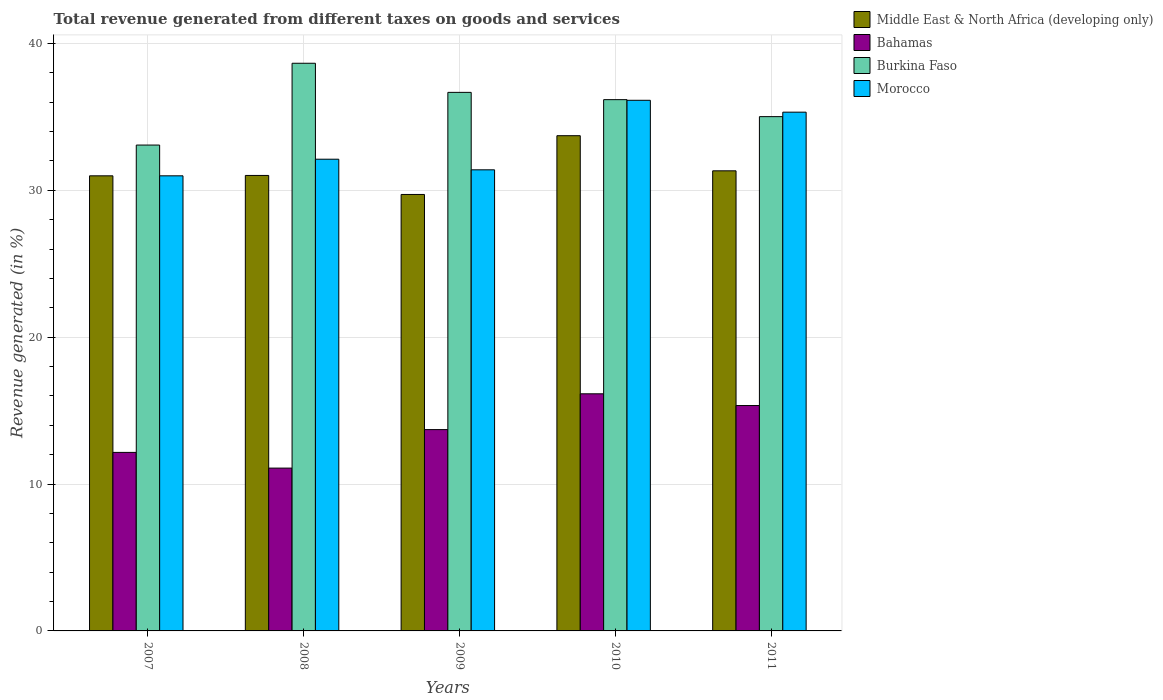How many different coloured bars are there?
Provide a succinct answer. 4. How many groups of bars are there?
Your response must be concise. 5. How many bars are there on the 2nd tick from the left?
Provide a succinct answer. 4. In how many cases, is the number of bars for a given year not equal to the number of legend labels?
Keep it short and to the point. 0. What is the total revenue generated in Morocco in 2009?
Provide a short and direct response. 31.4. Across all years, what is the maximum total revenue generated in Morocco?
Ensure brevity in your answer.  36.13. Across all years, what is the minimum total revenue generated in Middle East & North Africa (developing only)?
Provide a short and direct response. 29.72. In which year was the total revenue generated in Bahamas maximum?
Make the answer very short. 2010. In which year was the total revenue generated in Morocco minimum?
Offer a very short reply. 2007. What is the total total revenue generated in Burkina Faso in the graph?
Your answer should be compact. 179.61. What is the difference between the total revenue generated in Morocco in 2009 and that in 2010?
Keep it short and to the point. -4.73. What is the difference between the total revenue generated in Morocco in 2011 and the total revenue generated in Burkina Faso in 2010?
Make the answer very short. -0.85. What is the average total revenue generated in Morocco per year?
Ensure brevity in your answer.  33.19. In the year 2010, what is the difference between the total revenue generated in Middle East & North Africa (developing only) and total revenue generated in Burkina Faso?
Your answer should be very brief. -2.45. What is the ratio of the total revenue generated in Bahamas in 2009 to that in 2011?
Your answer should be very brief. 0.89. Is the total revenue generated in Burkina Faso in 2009 less than that in 2011?
Give a very brief answer. No. What is the difference between the highest and the second highest total revenue generated in Middle East & North Africa (developing only)?
Provide a succinct answer. 2.39. What is the difference between the highest and the lowest total revenue generated in Middle East & North Africa (developing only)?
Provide a succinct answer. 4. In how many years, is the total revenue generated in Burkina Faso greater than the average total revenue generated in Burkina Faso taken over all years?
Keep it short and to the point. 3. Is the sum of the total revenue generated in Middle East & North Africa (developing only) in 2008 and 2011 greater than the maximum total revenue generated in Bahamas across all years?
Your answer should be compact. Yes. Is it the case that in every year, the sum of the total revenue generated in Burkina Faso and total revenue generated in Middle East & North Africa (developing only) is greater than the sum of total revenue generated in Bahamas and total revenue generated in Morocco?
Provide a succinct answer. No. What does the 2nd bar from the left in 2009 represents?
Offer a terse response. Bahamas. What does the 3rd bar from the right in 2009 represents?
Offer a very short reply. Bahamas. Is it the case that in every year, the sum of the total revenue generated in Burkina Faso and total revenue generated in Bahamas is greater than the total revenue generated in Middle East & North Africa (developing only)?
Provide a succinct answer. Yes. Does the graph contain any zero values?
Keep it short and to the point. No. Does the graph contain grids?
Your answer should be very brief. Yes. How are the legend labels stacked?
Your response must be concise. Vertical. What is the title of the graph?
Offer a terse response. Total revenue generated from different taxes on goods and services. Does "East Asia (all income levels)" appear as one of the legend labels in the graph?
Provide a short and direct response. No. What is the label or title of the Y-axis?
Your answer should be very brief. Revenue generated (in %). What is the Revenue generated (in %) of Middle East & North Africa (developing only) in 2007?
Your answer should be compact. 30.99. What is the Revenue generated (in %) in Bahamas in 2007?
Keep it short and to the point. 12.16. What is the Revenue generated (in %) of Burkina Faso in 2007?
Your answer should be compact. 33.08. What is the Revenue generated (in %) of Morocco in 2007?
Your response must be concise. 30.99. What is the Revenue generated (in %) of Middle East & North Africa (developing only) in 2008?
Provide a short and direct response. 31.02. What is the Revenue generated (in %) in Bahamas in 2008?
Make the answer very short. 11.09. What is the Revenue generated (in %) in Burkina Faso in 2008?
Your response must be concise. 38.66. What is the Revenue generated (in %) in Morocco in 2008?
Make the answer very short. 32.12. What is the Revenue generated (in %) in Middle East & North Africa (developing only) in 2009?
Your answer should be very brief. 29.72. What is the Revenue generated (in %) of Bahamas in 2009?
Ensure brevity in your answer.  13.71. What is the Revenue generated (in %) in Burkina Faso in 2009?
Give a very brief answer. 36.67. What is the Revenue generated (in %) of Morocco in 2009?
Offer a very short reply. 31.4. What is the Revenue generated (in %) in Middle East & North Africa (developing only) in 2010?
Provide a succinct answer. 33.72. What is the Revenue generated (in %) of Bahamas in 2010?
Provide a short and direct response. 16.15. What is the Revenue generated (in %) in Burkina Faso in 2010?
Offer a terse response. 36.18. What is the Revenue generated (in %) in Morocco in 2010?
Make the answer very short. 36.13. What is the Revenue generated (in %) in Middle East & North Africa (developing only) in 2011?
Provide a succinct answer. 31.33. What is the Revenue generated (in %) of Bahamas in 2011?
Offer a very short reply. 15.35. What is the Revenue generated (in %) in Burkina Faso in 2011?
Make the answer very short. 35.02. What is the Revenue generated (in %) of Morocco in 2011?
Offer a very short reply. 35.33. Across all years, what is the maximum Revenue generated (in %) in Middle East & North Africa (developing only)?
Your answer should be compact. 33.72. Across all years, what is the maximum Revenue generated (in %) of Bahamas?
Keep it short and to the point. 16.15. Across all years, what is the maximum Revenue generated (in %) of Burkina Faso?
Provide a short and direct response. 38.66. Across all years, what is the maximum Revenue generated (in %) in Morocco?
Offer a terse response. 36.13. Across all years, what is the minimum Revenue generated (in %) of Middle East & North Africa (developing only)?
Offer a very short reply. 29.72. Across all years, what is the minimum Revenue generated (in %) of Bahamas?
Offer a terse response. 11.09. Across all years, what is the minimum Revenue generated (in %) of Burkina Faso?
Your answer should be compact. 33.08. Across all years, what is the minimum Revenue generated (in %) of Morocco?
Make the answer very short. 30.99. What is the total Revenue generated (in %) of Middle East & North Africa (developing only) in the graph?
Provide a succinct answer. 156.78. What is the total Revenue generated (in %) in Bahamas in the graph?
Your answer should be very brief. 68.45. What is the total Revenue generated (in %) of Burkina Faso in the graph?
Keep it short and to the point. 179.61. What is the total Revenue generated (in %) in Morocco in the graph?
Provide a short and direct response. 165.97. What is the difference between the Revenue generated (in %) of Middle East & North Africa (developing only) in 2007 and that in 2008?
Provide a short and direct response. -0.03. What is the difference between the Revenue generated (in %) of Bahamas in 2007 and that in 2008?
Offer a terse response. 1.07. What is the difference between the Revenue generated (in %) of Burkina Faso in 2007 and that in 2008?
Offer a very short reply. -5.57. What is the difference between the Revenue generated (in %) in Morocco in 2007 and that in 2008?
Offer a very short reply. -1.13. What is the difference between the Revenue generated (in %) in Middle East & North Africa (developing only) in 2007 and that in 2009?
Your response must be concise. 1.27. What is the difference between the Revenue generated (in %) of Bahamas in 2007 and that in 2009?
Provide a short and direct response. -1.55. What is the difference between the Revenue generated (in %) of Burkina Faso in 2007 and that in 2009?
Keep it short and to the point. -3.59. What is the difference between the Revenue generated (in %) in Morocco in 2007 and that in 2009?
Give a very brief answer. -0.41. What is the difference between the Revenue generated (in %) of Middle East & North Africa (developing only) in 2007 and that in 2010?
Your response must be concise. -2.73. What is the difference between the Revenue generated (in %) in Bahamas in 2007 and that in 2010?
Give a very brief answer. -3.99. What is the difference between the Revenue generated (in %) of Burkina Faso in 2007 and that in 2010?
Your answer should be compact. -3.09. What is the difference between the Revenue generated (in %) of Morocco in 2007 and that in 2010?
Ensure brevity in your answer.  -5.14. What is the difference between the Revenue generated (in %) in Middle East & North Africa (developing only) in 2007 and that in 2011?
Give a very brief answer. -0.34. What is the difference between the Revenue generated (in %) in Bahamas in 2007 and that in 2011?
Provide a succinct answer. -3.19. What is the difference between the Revenue generated (in %) of Burkina Faso in 2007 and that in 2011?
Provide a short and direct response. -1.94. What is the difference between the Revenue generated (in %) of Morocco in 2007 and that in 2011?
Provide a succinct answer. -4.34. What is the difference between the Revenue generated (in %) in Middle East & North Africa (developing only) in 2008 and that in 2009?
Your response must be concise. 1.29. What is the difference between the Revenue generated (in %) in Bahamas in 2008 and that in 2009?
Provide a succinct answer. -2.62. What is the difference between the Revenue generated (in %) in Burkina Faso in 2008 and that in 2009?
Your answer should be compact. 1.98. What is the difference between the Revenue generated (in %) in Morocco in 2008 and that in 2009?
Give a very brief answer. 0.72. What is the difference between the Revenue generated (in %) of Middle East & North Africa (developing only) in 2008 and that in 2010?
Your answer should be very brief. -2.71. What is the difference between the Revenue generated (in %) of Bahamas in 2008 and that in 2010?
Your answer should be very brief. -5.06. What is the difference between the Revenue generated (in %) in Burkina Faso in 2008 and that in 2010?
Make the answer very short. 2.48. What is the difference between the Revenue generated (in %) of Morocco in 2008 and that in 2010?
Provide a short and direct response. -4.01. What is the difference between the Revenue generated (in %) of Middle East & North Africa (developing only) in 2008 and that in 2011?
Offer a terse response. -0.31. What is the difference between the Revenue generated (in %) of Bahamas in 2008 and that in 2011?
Make the answer very short. -4.26. What is the difference between the Revenue generated (in %) of Burkina Faso in 2008 and that in 2011?
Ensure brevity in your answer.  3.63. What is the difference between the Revenue generated (in %) of Morocco in 2008 and that in 2011?
Offer a very short reply. -3.2. What is the difference between the Revenue generated (in %) in Middle East & North Africa (developing only) in 2009 and that in 2010?
Make the answer very short. -4. What is the difference between the Revenue generated (in %) in Bahamas in 2009 and that in 2010?
Your answer should be very brief. -2.44. What is the difference between the Revenue generated (in %) in Burkina Faso in 2009 and that in 2010?
Provide a succinct answer. 0.5. What is the difference between the Revenue generated (in %) of Morocco in 2009 and that in 2010?
Your response must be concise. -4.73. What is the difference between the Revenue generated (in %) of Middle East & North Africa (developing only) in 2009 and that in 2011?
Provide a succinct answer. -1.61. What is the difference between the Revenue generated (in %) in Bahamas in 2009 and that in 2011?
Give a very brief answer. -1.64. What is the difference between the Revenue generated (in %) of Burkina Faso in 2009 and that in 2011?
Offer a very short reply. 1.65. What is the difference between the Revenue generated (in %) in Morocco in 2009 and that in 2011?
Make the answer very short. -3.93. What is the difference between the Revenue generated (in %) of Middle East & North Africa (developing only) in 2010 and that in 2011?
Provide a succinct answer. 2.39. What is the difference between the Revenue generated (in %) of Bahamas in 2010 and that in 2011?
Your answer should be compact. 0.8. What is the difference between the Revenue generated (in %) in Burkina Faso in 2010 and that in 2011?
Provide a succinct answer. 1.16. What is the difference between the Revenue generated (in %) in Morocco in 2010 and that in 2011?
Ensure brevity in your answer.  0.81. What is the difference between the Revenue generated (in %) of Middle East & North Africa (developing only) in 2007 and the Revenue generated (in %) of Bahamas in 2008?
Provide a short and direct response. 19.9. What is the difference between the Revenue generated (in %) in Middle East & North Africa (developing only) in 2007 and the Revenue generated (in %) in Burkina Faso in 2008?
Keep it short and to the point. -7.67. What is the difference between the Revenue generated (in %) of Middle East & North Africa (developing only) in 2007 and the Revenue generated (in %) of Morocco in 2008?
Your answer should be compact. -1.13. What is the difference between the Revenue generated (in %) in Bahamas in 2007 and the Revenue generated (in %) in Burkina Faso in 2008?
Provide a succinct answer. -26.5. What is the difference between the Revenue generated (in %) of Bahamas in 2007 and the Revenue generated (in %) of Morocco in 2008?
Ensure brevity in your answer.  -19.97. What is the difference between the Revenue generated (in %) in Burkina Faso in 2007 and the Revenue generated (in %) in Morocco in 2008?
Offer a terse response. 0.96. What is the difference between the Revenue generated (in %) in Middle East & North Africa (developing only) in 2007 and the Revenue generated (in %) in Bahamas in 2009?
Provide a short and direct response. 17.28. What is the difference between the Revenue generated (in %) of Middle East & North Africa (developing only) in 2007 and the Revenue generated (in %) of Burkina Faso in 2009?
Offer a terse response. -5.68. What is the difference between the Revenue generated (in %) in Middle East & North Africa (developing only) in 2007 and the Revenue generated (in %) in Morocco in 2009?
Make the answer very short. -0.41. What is the difference between the Revenue generated (in %) in Bahamas in 2007 and the Revenue generated (in %) in Burkina Faso in 2009?
Offer a very short reply. -24.52. What is the difference between the Revenue generated (in %) of Bahamas in 2007 and the Revenue generated (in %) of Morocco in 2009?
Ensure brevity in your answer.  -19.24. What is the difference between the Revenue generated (in %) of Burkina Faso in 2007 and the Revenue generated (in %) of Morocco in 2009?
Give a very brief answer. 1.69. What is the difference between the Revenue generated (in %) of Middle East & North Africa (developing only) in 2007 and the Revenue generated (in %) of Bahamas in 2010?
Your response must be concise. 14.84. What is the difference between the Revenue generated (in %) in Middle East & North Africa (developing only) in 2007 and the Revenue generated (in %) in Burkina Faso in 2010?
Give a very brief answer. -5.19. What is the difference between the Revenue generated (in %) in Middle East & North Africa (developing only) in 2007 and the Revenue generated (in %) in Morocco in 2010?
Keep it short and to the point. -5.14. What is the difference between the Revenue generated (in %) in Bahamas in 2007 and the Revenue generated (in %) in Burkina Faso in 2010?
Offer a very short reply. -24.02. What is the difference between the Revenue generated (in %) of Bahamas in 2007 and the Revenue generated (in %) of Morocco in 2010?
Give a very brief answer. -23.98. What is the difference between the Revenue generated (in %) in Burkina Faso in 2007 and the Revenue generated (in %) in Morocco in 2010?
Make the answer very short. -3.05. What is the difference between the Revenue generated (in %) of Middle East & North Africa (developing only) in 2007 and the Revenue generated (in %) of Bahamas in 2011?
Ensure brevity in your answer.  15.64. What is the difference between the Revenue generated (in %) of Middle East & North Africa (developing only) in 2007 and the Revenue generated (in %) of Burkina Faso in 2011?
Offer a very short reply. -4.03. What is the difference between the Revenue generated (in %) in Middle East & North Africa (developing only) in 2007 and the Revenue generated (in %) in Morocco in 2011?
Offer a terse response. -4.34. What is the difference between the Revenue generated (in %) of Bahamas in 2007 and the Revenue generated (in %) of Burkina Faso in 2011?
Your answer should be very brief. -22.86. What is the difference between the Revenue generated (in %) in Bahamas in 2007 and the Revenue generated (in %) in Morocco in 2011?
Give a very brief answer. -23.17. What is the difference between the Revenue generated (in %) in Burkina Faso in 2007 and the Revenue generated (in %) in Morocco in 2011?
Your response must be concise. -2.24. What is the difference between the Revenue generated (in %) in Middle East & North Africa (developing only) in 2008 and the Revenue generated (in %) in Bahamas in 2009?
Your answer should be very brief. 17.31. What is the difference between the Revenue generated (in %) in Middle East & North Africa (developing only) in 2008 and the Revenue generated (in %) in Burkina Faso in 2009?
Your response must be concise. -5.66. What is the difference between the Revenue generated (in %) in Middle East & North Africa (developing only) in 2008 and the Revenue generated (in %) in Morocco in 2009?
Offer a very short reply. -0.38. What is the difference between the Revenue generated (in %) of Bahamas in 2008 and the Revenue generated (in %) of Burkina Faso in 2009?
Keep it short and to the point. -25.59. What is the difference between the Revenue generated (in %) in Bahamas in 2008 and the Revenue generated (in %) in Morocco in 2009?
Offer a terse response. -20.31. What is the difference between the Revenue generated (in %) of Burkina Faso in 2008 and the Revenue generated (in %) of Morocco in 2009?
Provide a short and direct response. 7.26. What is the difference between the Revenue generated (in %) in Middle East & North Africa (developing only) in 2008 and the Revenue generated (in %) in Bahamas in 2010?
Give a very brief answer. 14.87. What is the difference between the Revenue generated (in %) of Middle East & North Africa (developing only) in 2008 and the Revenue generated (in %) of Burkina Faso in 2010?
Offer a very short reply. -5.16. What is the difference between the Revenue generated (in %) of Middle East & North Africa (developing only) in 2008 and the Revenue generated (in %) of Morocco in 2010?
Your answer should be compact. -5.12. What is the difference between the Revenue generated (in %) of Bahamas in 2008 and the Revenue generated (in %) of Burkina Faso in 2010?
Offer a very short reply. -25.09. What is the difference between the Revenue generated (in %) of Bahamas in 2008 and the Revenue generated (in %) of Morocco in 2010?
Ensure brevity in your answer.  -25.05. What is the difference between the Revenue generated (in %) in Burkina Faso in 2008 and the Revenue generated (in %) in Morocco in 2010?
Give a very brief answer. 2.52. What is the difference between the Revenue generated (in %) in Middle East & North Africa (developing only) in 2008 and the Revenue generated (in %) in Bahamas in 2011?
Your response must be concise. 15.67. What is the difference between the Revenue generated (in %) in Middle East & North Africa (developing only) in 2008 and the Revenue generated (in %) in Burkina Faso in 2011?
Your answer should be very brief. -4. What is the difference between the Revenue generated (in %) in Middle East & North Africa (developing only) in 2008 and the Revenue generated (in %) in Morocco in 2011?
Offer a very short reply. -4.31. What is the difference between the Revenue generated (in %) of Bahamas in 2008 and the Revenue generated (in %) of Burkina Faso in 2011?
Offer a terse response. -23.93. What is the difference between the Revenue generated (in %) in Bahamas in 2008 and the Revenue generated (in %) in Morocco in 2011?
Make the answer very short. -24.24. What is the difference between the Revenue generated (in %) in Burkina Faso in 2008 and the Revenue generated (in %) in Morocco in 2011?
Offer a terse response. 3.33. What is the difference between the Revenue generated (in %) of Middle East & North Africa (developing only) in 2009 and the Revenue generated (in %) of Bahamas in 2010?
Offer a very short reply. 13.57. What is the difference between the Revenue generated (in %) in Middle East & North Africa (developing only) in 2009 and the Revenue generated (in %) in Burkina Faso in 2010?
Your response must be concise. -6.46. What is the difference between the Revenue generated (in %) of Middle East & North Africa (developing only) in 2009 and the Revenue generated (in %) of Morocco in 2010?
Your answer should be compact. -6.41. What is the difference between the Revenue generated (in %) of Bahamas in 2009 and the Revenue generated (in %) of Burkina Faso in 2010?
Your answer should be very brief. -22.47. What is the difference between the Revenue generated (in %) in Bahamas in 2009 and the Revenue generated (in %) in Morocco in 2010?
Your answer should be very brief. -22.42. What is the difference between the Revenue generated (in %) in Burkina Faso in 2009 and the Revenue generated (in %) in Morocco in 2010?
Ensure brevity in your answer.  0.54. What is the difference between the Revenue generated (in %) of Middle East & North Africa (developing only) in 2009 and the Revenue generated (in %) of Bahamas in 2011?
Your response must be concise. 14.37. What is the difference between the Revenue generated (in %) in Middle East & North Africa (developing only) in 2009 and the Revenue generated (in %) in Burkina Faso in 2011?
Your answer should be compact. -5.3. What is the difference between the Revenue generated (in %) in Middle East & North Africa (developing only) in 2009 and the Revenue generated (in %) in Morocco in 2011?
Offer a very short reply. -5.6. What is the difference between the Revenue generated (in %) of Bahamas in 2009 and the Revenue generated (in %) of Burkina Faso in 2011?
Offer a terse response. -21.31. What is the difference between the Revenue generated (in %) in Bahamas in 2009 and the Revenue generated (in %) in Morocco in 2011?
Offer a very short reply. -21.62. What is the difference between the Revenue generated (in %) of Burkina Faso in 2009 and the Revenue generated (in %) of Morocco in 2011?
Make the answer very short. 1.35. What is the difference between the Revenue generated (in %) of Middle East & North Africa (developing only) in 2010 and the Revenue generated (in %) of Bahamas in 2011?
Your response must be concise. 18.38. What is the difference between the Revenue generated (in %) of Middle East & North Africa (developing only) in 2010 and the Revenue generated (in %) of Burkina Faso in 2011?
Provide a short and direct response. -1.3. What is the difference between the Revenue generated (in %) of Middle East & North Africa (developing only) in 2010 and the Revenue generated (in %) of Morocco in 2011?
Your answer should be compact. -1.6. What is the difference between the Revenue generated (in %) in Bahamas in 2010 and the Revenue generated (in %) in Burkina Faso in 2011?
Give a very brief answer. -18.87. What is the difference between the Revenue generated (in %) of Bahamas in 2010 and the Revenue generated (in %) of Morocco in 2011?
Give a very brief answer. -19.18. What is the difference between the Revenue generated (in %) in Burkina Faso in 2010 and the Revenue generated (in %) in Morocco in 2011?
Ensure brevity in your answer.  0.85. What is the average Revenue generated (in %) in Middle East & North Africa (developing only) per year?
Your response must be concise. 31.36. What is the average Revenue generated (in %) of Bahamas per year?
Keep it short and to the point. 13.69. What is the average Revenue generated (in %) in Burkina Faso per year?
Your response must be concise. 35.92. What is the average Revenue generated (in %) in Morocco per year?
Offer a very short reply. 33.19. In the year 2007, what is the difference between the Revenue generated (in %) of Middle East & North Africa (developing only) and Revenue generated (in %) of Bahamas?
Keep it short and to the point. 18.83. In the year 2007, what is the difference between the Revenue generated (in %) of Middle East & North Africa (developing only) and Revenue generated (in %) of Burkina Faso?
Your answer should be very brief. -2.09. In the year 2007, what is the difference between the Revenue generated (in %) of Bahamas and Revenue generated (in %) of Burkina Faso?
Ensure brevity in your answer.  -20.93. In the year 2007, what is the difference between the Revenue generated (in %) of Bahamas and Revenue generated (in %) of Morocco?
Keep it short and to the point. -18.83. In the year 2007, what is the difference between the Revenue generated (in %) in Burkina Faso and Revenue generated (in %) in Morocco?
Make the answer very short. 2.09. In the year 2008, what is the difference between the Revenue generated (in %) in Middle East & North Africa (developing only) and Revenue generated (in %) in Bahamas?
Your answer should be compact. 19.93. In the year 2008, what is the difference between the Revenue generated (in %) in Middle East & North Africa (developing only) and Revenue generated (in %) in Burkina Faso?
Provide a short and direct response. -7.64. In the year 2008, what is the difference between the Revenue generated (in %) of Middle East & North Africa (developing only) and Revenue generated (in %) of Morocco?
Give a very brief answer. -1.11. In the year 2008, what is the difference between the Revenue generated (in %) of Bahamas and Revenue generated (in %) of Burkina Faso?
Offer a very short reply. -27.57. In the year 2008, what is the difference between the Revenue generated (in %) in Bahamas and Revenue generated (in %) in Morocco?
Provide a succinct answer. -21.03. In the year 2008, what is the difference between the Revenue generated (in %) of Burkina Faso and Revenue generated (in %) of Morocco?
Your answer should be compact. 6.53. In the year 2009, what is the difference between the Revenue generated (in %) of Middle East & North Africa (developing only) and Revenue generated (in %) of Bahamas?
Keep it short and to the point. 16.01. In the year 2009, what is the difference between the Revenue generated (in %) of Middle East & North Africa (developing only) and Revenue generated (in %) of Burkina Faso?
Provide a short and direct response. -6.95. In the year 2009, what is the difference between the Revenue generated (in %) of Middle East & North Africa (developing only) and Revenue generated (in %) of Morocco?
Ensure brevity in your answer.  -1.68. In the year 2009, what is the difference between the Revenue generated (in %) in Bahamas and Revenue generated (in %) in Burkina Faso?
Ensure brevity in your answer.  -22.96. In the year 2009, what is the difference between the Revenue generated (in %) in Bahamas and Revenue generated (in %) in Morocco?
Provide a succinct answer. -17.69. In the year 2009, what is the difference between the Revenue generated (in %) in Burkina Faso and Revenue generated (in %) in Morocco?
Ensure brevity in your answer.  5.27. In the year 2010, what is the difference between the Revenue generated (in %) of Middle East & North Africa (developing only) and Revenue generated (in %) of Bahamas?
Your response must be concise. 17.58. In the year 2010, what is the difference between the Revenue generated (in %) in Middle East & North Africa (developing only) and Revenue generated (in %) in Burkina Faso?
Provide a short and direct response. -2.45. In the year 2010, what is the difference between the Revenue generated (in %) in Middle East & North Africa (developing only) and Revenue generated (in %) in Morocco?
Give a very brief answer. -2.41. In the year 2010, what is the difference between the Revenue generated (in %) in Bahamas and Revenue generated (in %) in Burkina Faso?
Keep it short and to the point. -20.03. In the year 2010, what is the difference between the Revenue generated (in %) in Bahamas and Revenue generated (in %) in Morocco?
Make the answer very short. -19.99. In the year 2010, what is the difference between the Revenue generated (in %) in Burkina Faso and Revenue generated (in %) in Morocco?
Make the answer very short. 0.04. In the year 2011, what is the difference between the Revenue generated (in %) of Middle East & North Africa (developing only) and Revenue generated (in %) of Bahamas?
Your answer should be very brief. 15.98. In the year 2011, what is the difference between the Revenue generated (in %) of Middle East & North Africa (developing only) and Revenue generated (in %) of Burkina Faso?
Your response must be concise. -3.69. In the year 2011, what is the difference between the Revenue generated (in %) of Middle East & North Africa (developing only) and Revenue generated (in %) of Morocco?
Offer a very short reply. -4. In the year 2011, what is the difference between the Revenue generated (in %) of Bahamas and Revenue generated (in %) of Burkina Faso?
Give a very brief answer. -19.67. In the year 2011, what is the difference between the Revenue generated (in %) in Bahamas and Revenue generated (in %) in Morocco?
Offer a terse response. -19.98. In the year 2011, what is the difference between the Revenue generated (in %) of Burkina Faso and Revenue generated (in %) of Morocco?
Offer a very short reply. -0.3. What is the ratio of the Revenue generated (in %) in Middle East & North Africa (developing only) in 2007 to that in 2008?
Provide a short and direct response. 1. What is the ratio of the Revenue generated (in %) of Bahamas in 2007 to that in 2008?
Make the answer very short. 1.1. What is the ratio of the Revenue generated (in %) in Burkina Faso in 2007 to that in 2008?
Provide a short and direct response. 0.86. What is the ratio of the Revenue generated (in %) in Morocco in 2007 to that in 2008?
Provide a short and direct response. 0.96. What is the ratio of the Revenue generated (in %) in Middle East & North Africa (developing only) in 2007 to that in 2009?
Your answer should be compact. 1.04. What is the ratio of the Revenue generated (in %) of Bahamas in 2007 to that in 2009?
Offer a terse response. 0.89. What is the ratio of the Revenue generated (in %) in Burkina Faso in 2007 to that in 2009?
Ensure brevity in your answer.  0.9. What is the ratio of the Revenue generated (in %) in Middle East & North Africa (developing only) in 2007 to that in 2010?
Your answer should be very brief. 0.92. What is the ratio of the Revenue generated (in %) in Bahamas in 2007 to that in 2010?
Provide a succinct answer. 0.75. What is the ratio of the Revenue generated (in %) of Burkina Faso in 2007 to that in 2010?
Your answer should be very brief. 0.91. What is the ratio of the Revenue generated (in %) in Morocco in 2007 to that in 2010?
Offer a terse response. 0.86. What is the ratio of the Revenue generated (in %) of Bahamas in 2007 to that in 2011?
Give a very brief answer. 0.79. What is the ratio of the Revenue generated (in %) of Burkina Faso in 2007 to that in 2011?
Your answer should be very brief. 0.94. What is the ratio of the Revenue generated (in %) of Morocco in 2007 to that in 2011?
Your response must be concise. 0.88. What is the ratio of the Revenue generated (in %) in Middle East & North Africa (developing only) in 2008 to that in 2009?
Keep it short and to the point. 1.04. What is the ratio of the Revenue generated (in %) of Bahamas in 2008 to that in 2009?
Provide a short and direct response. 0.81. What is the ratio of the Revenue generated (in %) in Burkina Faso in 2008 to that in 2009?
Your response must be concise. 1.05. What is the ratio of the Revenue generated (in %) of Middle East & North Africa (developing only) in 2008 to that in 2010?
Your answer should be very brief. 0.92. What is the ratio of the Revenue generated (in %) in Bahamas in 2008 to that in 2010?
Offer a very short reply. 0.69. What is the ratio of the Revenue generated (in %) of Burkina Faso in 2008 to that in 2010?
Your answer should be compact. 1.07. What is the ratio of the Revenue generated (in %) in Morocco in 2008 to that in 2010?
Ensure brevity in your answer.  0.89. What is the ratio of the Revenue generated (in %) of Middle East & North Africa (developing only) in 2008 to that in 2011?
Ensure brevity in your answer.  0.99. What is the ratio of the Revenue generated (in %) of Bahamas in 2008 to that in 2011?
Your response must be concise. 0.72. What is the ratio of the Revenue generated (in %) in Burkina Faso in 2008 to that in 2011?
Make the answer very short. 1.1. What is the ratio of the Revenue generated (in %) of Morocco in 2008 to that in 2011?
Your answer should be compact. 0.91. What is the ratio of the Revenue generated (in %) of Middle East & North Africa (developing only) in 2009 to that in 2010?
Offer a terse response. 0.88. What is the ratio of the Revenue generated (in %) in Bahamas in 2009 to that in 2010?
Your answer should be compact. 0.85. What is the ratio of the Revenue generated (in %) of Burkina Faso in 2009 to that in 2010?
Your answer should be very brief. 1.01. What is the ratio of the Revenue generated (in %) of Morocco in 2009 to that in 2010?
Offer a terse response. 0.87. What is the ratio of the Revenue generated (in %) in Middle East & North Africa (developing only) in 2009 to that in 2011?
Make the answer very short. 0.95. What is the ratio of the Revenue generated (in %) in Bahamas in 2009 to that in 2011?
Your response must be concise. 0.89. What is the ratio of the Revenue generated (in %) of Burkina Faso in 2009 to that in 2011?
Provide a short and direct response. 1.05. What is the ratio of the Revenue generated (in %) in Middle East & North Africa (developing only) in 2010 to that in 2011?
Provide a short and direct response. 1.08. What is the ratio of the Revenue generated (in %) in Bahamas in 2010 to that in 2011?
Make the answer very short. 1.05. What is the ratio of the Revenue generated (in %) of Burkina Faso in 2010 to that in 2011?
Offer a very short reply. 1.03. What is the ratio of the Revenue generated (in %) of Morocco in 2010 to that in 2011?
Offer a very short reply. 1.02. What is the difference between the highest and the second highest Revenue generated (in %) of Middle East & North Africa (developing only)?
Provide a short and direct response. 2.39. What is the difference between the highest and the second highest Revenue generated (in %) in Bahamas?
Provide a short and direct response. 0.8. What is the difference between the highest and the second highest Revenue generated (in %) of Burkina Faso?
Your answer should be compact. 1.98. What is the difference between the highest and the second highest Revenue generated (in %) in Morocco?
Provide a succinct answer. 0.81. What is the difference between the highest and the lowest Revenue generated (in %) in Middle East & North Africa (developing only)?
Offer a terse response. 4. What is the difference between the highest and the lowest Revenue generated (in %) of Bahamas?
Provide a short and direct response. 5.06. What is the difference between the highest and the lowest Revenue generated (in %) of Burkina Faso?
Provide a short and direct response. 5.57. What is the difference between the highest and the lowest Revenue generated (in %) of Morocco?
Offer a very short reply. 5.14. 